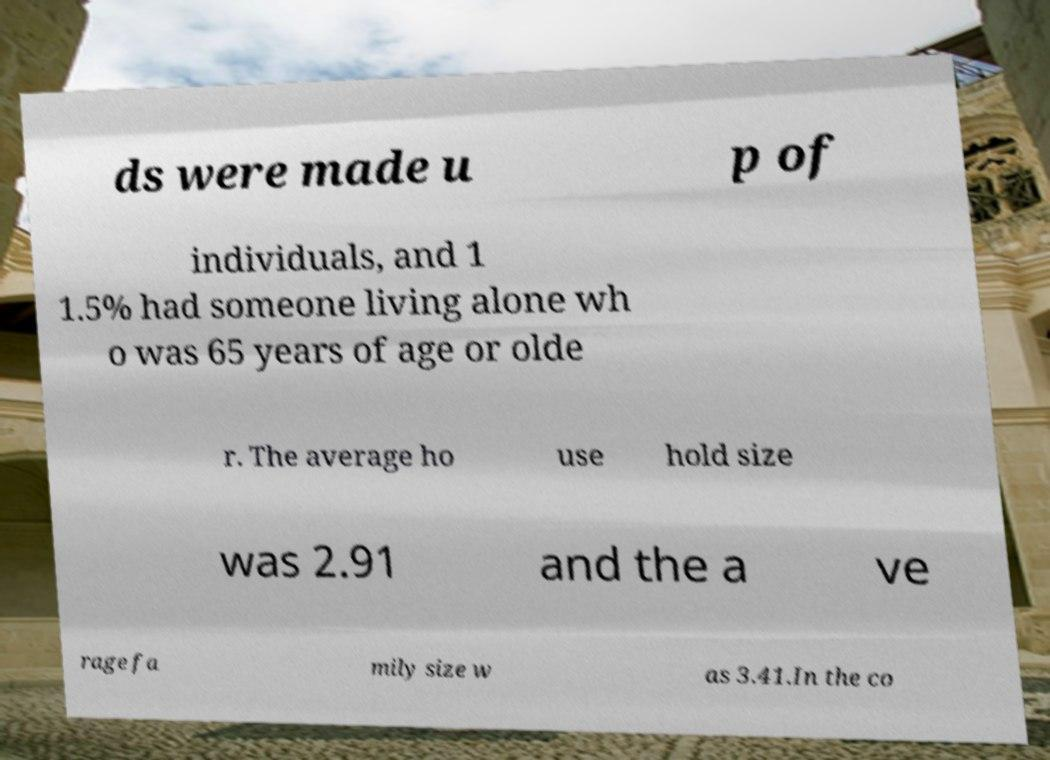Please read and relay the text visible in this image. What does it say? ds were made u p of individuals, and 1 1.5% had someone living alone wh o was 65 years of age or olde r. The average ho use hold size was 2.91 and the a ve rage fa mily size w as 3.41.In the co 